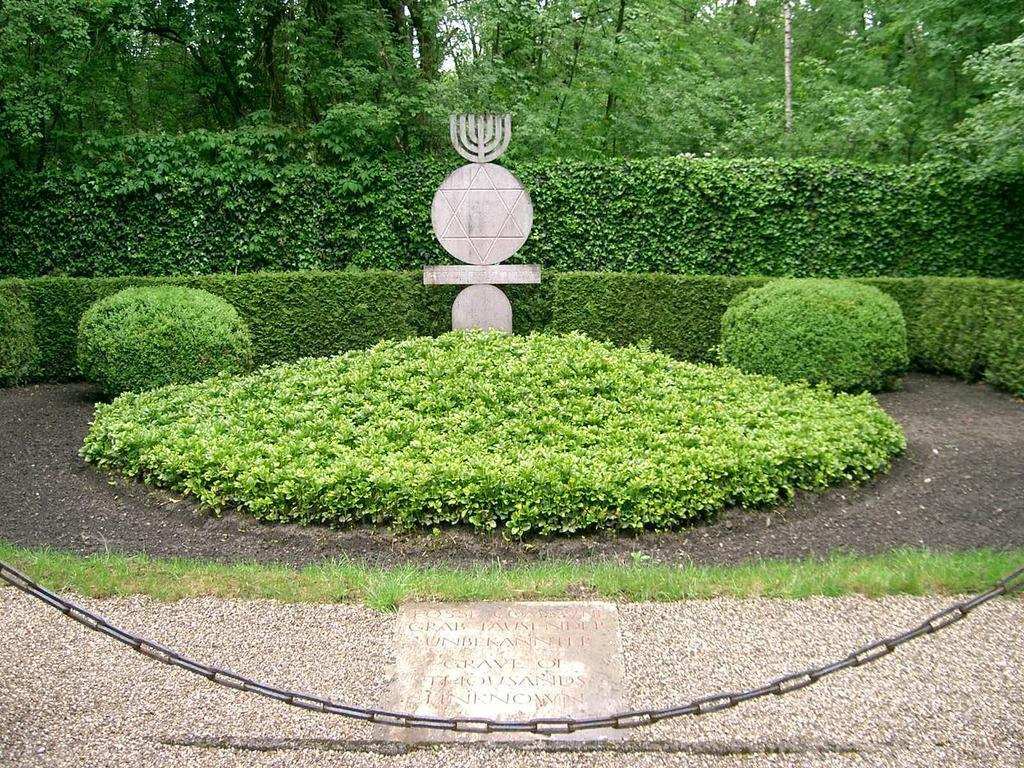What type of object can be seen in the image that is made of metal? There is a metal chain in the image. What is the wooden or similar material object in the image? There is a board in the image. What can be seen in the background of the image that indicates the presence of vegetation? There are plants, trees, and a concrete structure in the background of the image. What part of the natural environment is visible in the image? The sky is visible in the background of the image. How many planes are flying in the image? There are no planes visible in the image. What type of structure is used for sorting items in the image? There is no structure for sorting items present in the image. 